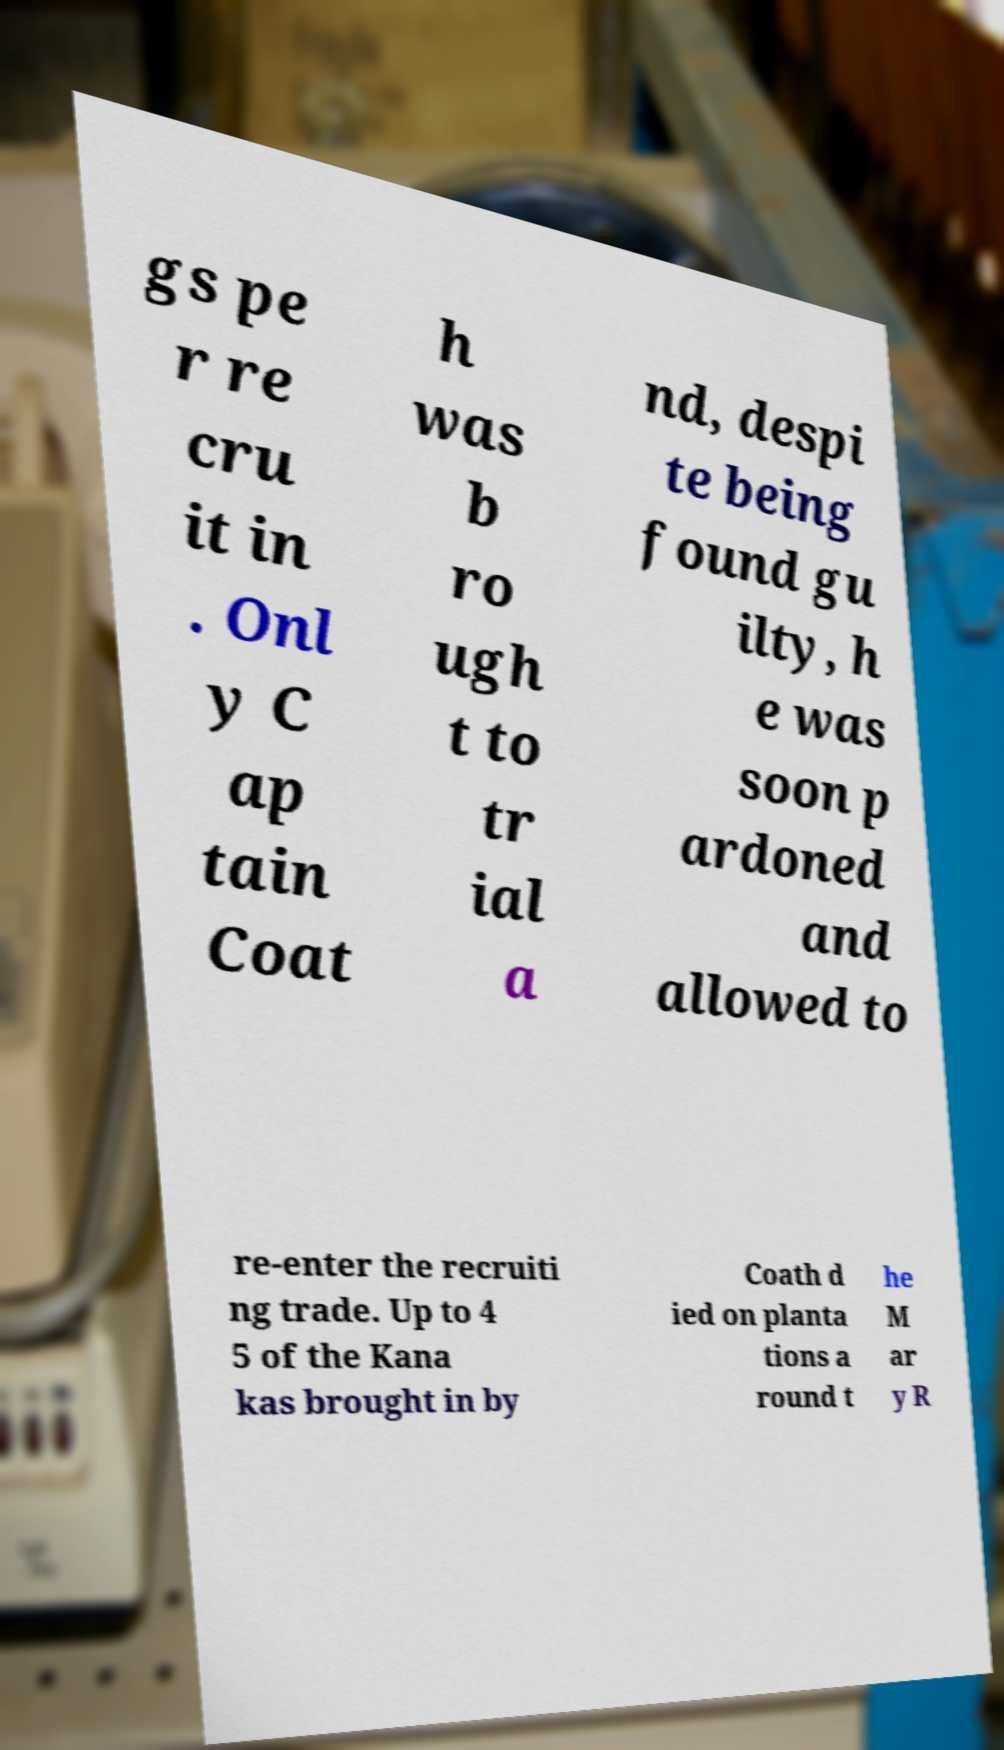I need the written content from this picture converted into text. Can you do that? gs pe r re cru it in . Onl y C ap tain Coat h was b ro ugh t to tr ial a nd, despi te being found gu ilty, h e was soon p ardoned and allowed to re-enter the recruiti ng trade. Up to 4 5 of the Kana kas brought in by Coath d ied on planta tions a round t he M ar y R 